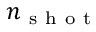<formula> <loc_0><loc_0><loc_500><loc_500>n _ { s h o t }</formula> 